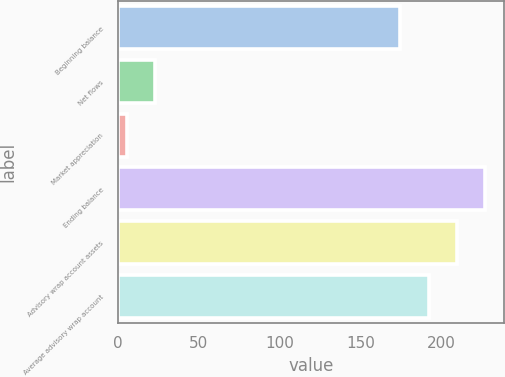Convert chart to OTSL. <chart><loc_0><loc_0><loc_500><loc_500><bar_chart><fcel>Beginning balance<fcel>Net flows<fcel>Market appreciation<fcel>Ending balance<fcel>Advisory wrap account assets<fcel>Average advisory wrap account<nl><fcel>174.7<fcel>22.82<fcel>5.3<fcel>227.26<fcel>209.74<fcel>192.22<nl></chart> 